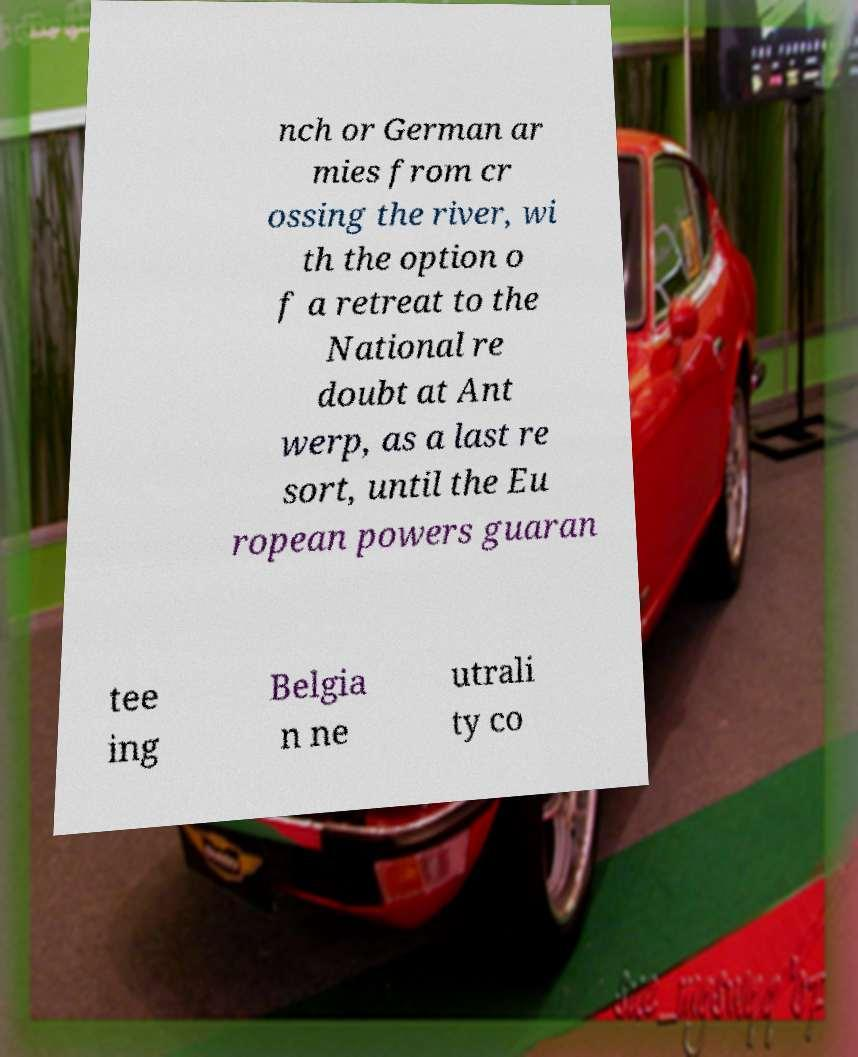What messages or text are displayed in this image? I need them in a readable, typed format. nch or German ar mies from cr ossing the river, wi th the option o f a retreat to the National re doubt at Ant werp, as a last re sort, until the Eu ropean powers guaran tee ing Belgia n ne utrali ty co 